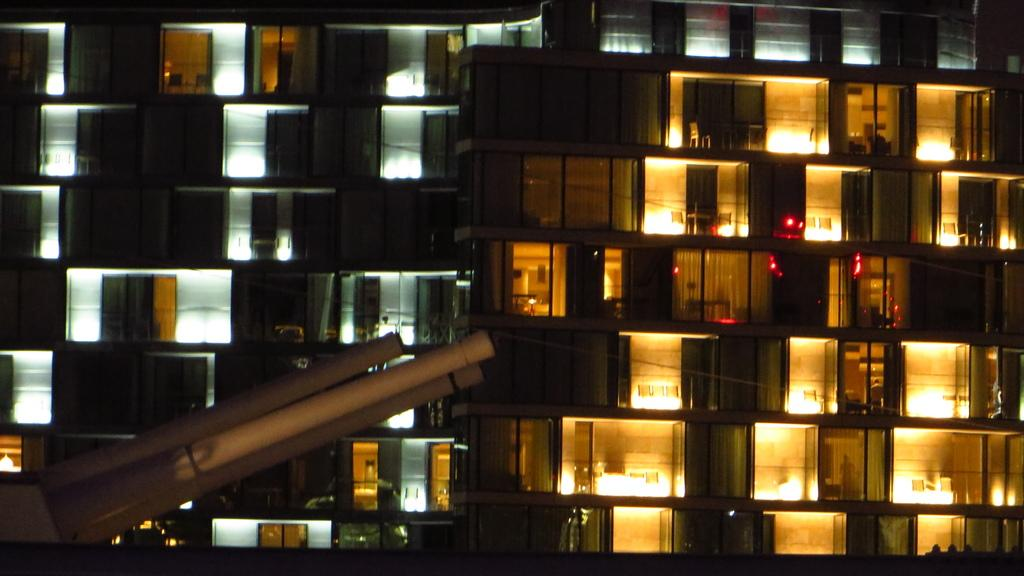What is the main object in front of the image? There is an object in front of the image, but its specific details are not mentioned in the facts. What type of building is visible behind the object? There is a building with glass walls behind the object. What can be seen through the glass walls of the building? Objects are visible through the glass walls of the building. What can be observed inside the building through the glass walls? Lights are visible inside the rooms through the glass walls. Where is the library located in the image? There is no mention of a library in the image or the provided facts. What type of brick is used to construct the building in the image? The building in the image has glass walls, so there is no mention of brick in the provided facts. 